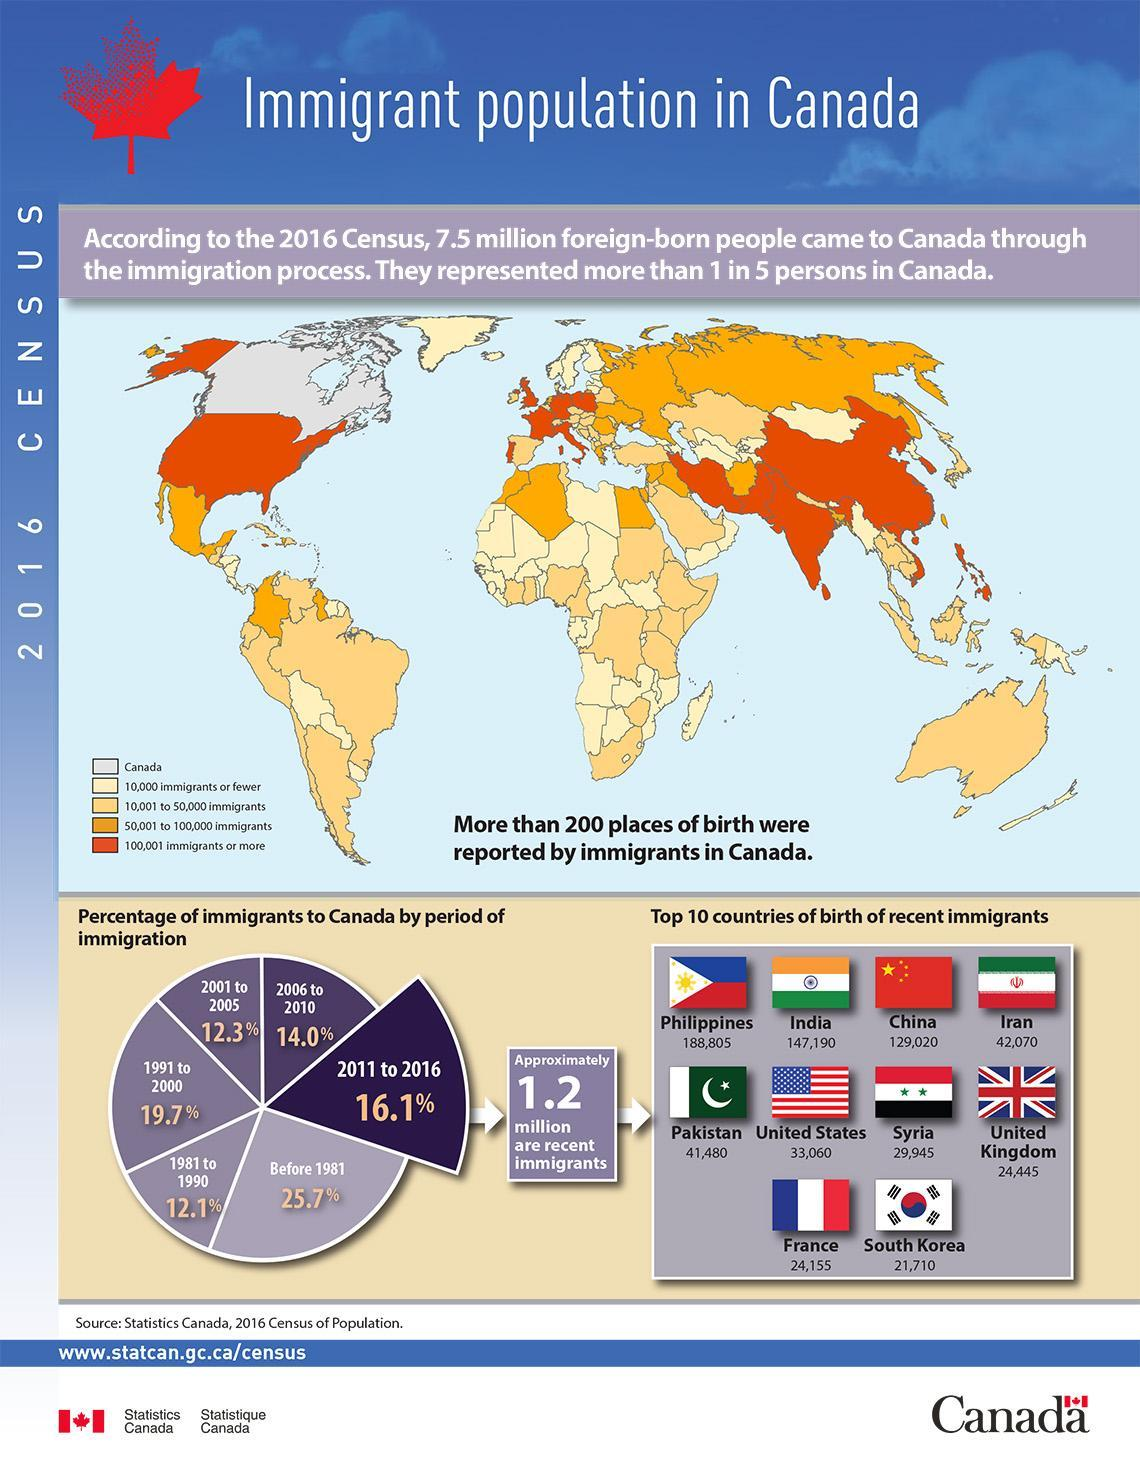How many people from South Korea migrated to Canada in the period 2011-2016?
Answer the question with a short phrase. 21,710 How many people from Iran migrated to Canada in the period 2011-2016? 42,070 How many people from china migrated to Canada in the period 2011-2016? 129,020 How many people reached Canada from India and China in the period 2011-2016? 2,76,210 How many people from UK migrated to Canada in the period 2011-2016? 24,445 Which color code is for the countries with immigrants to Canada more than 100,001- black, yellow, orange, purple? orange From which country second-lowest no of immigrants reached in the period 2011-2016? France If taken a sample of 5, what no: of people residing in Canada are actual Canadians? 4 In which year or period Canada had the highest percentage of immigrants? Before 1981 How many people migrated to Canada in the period 2011-2016 are of Indian Origin? 147,190 